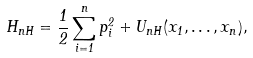Convert formula to latex. <formula><loc_0><loc_0><loc_500><loc_500>H _ { n H } = \frac { 1 } { 2 } \sum _ { i = 1 } ^ { n } p _ { i } ^ { 2 } + { U _ { n H } } ( x _ { 1 } , \dots , x _ { n } ) ,</formula> 